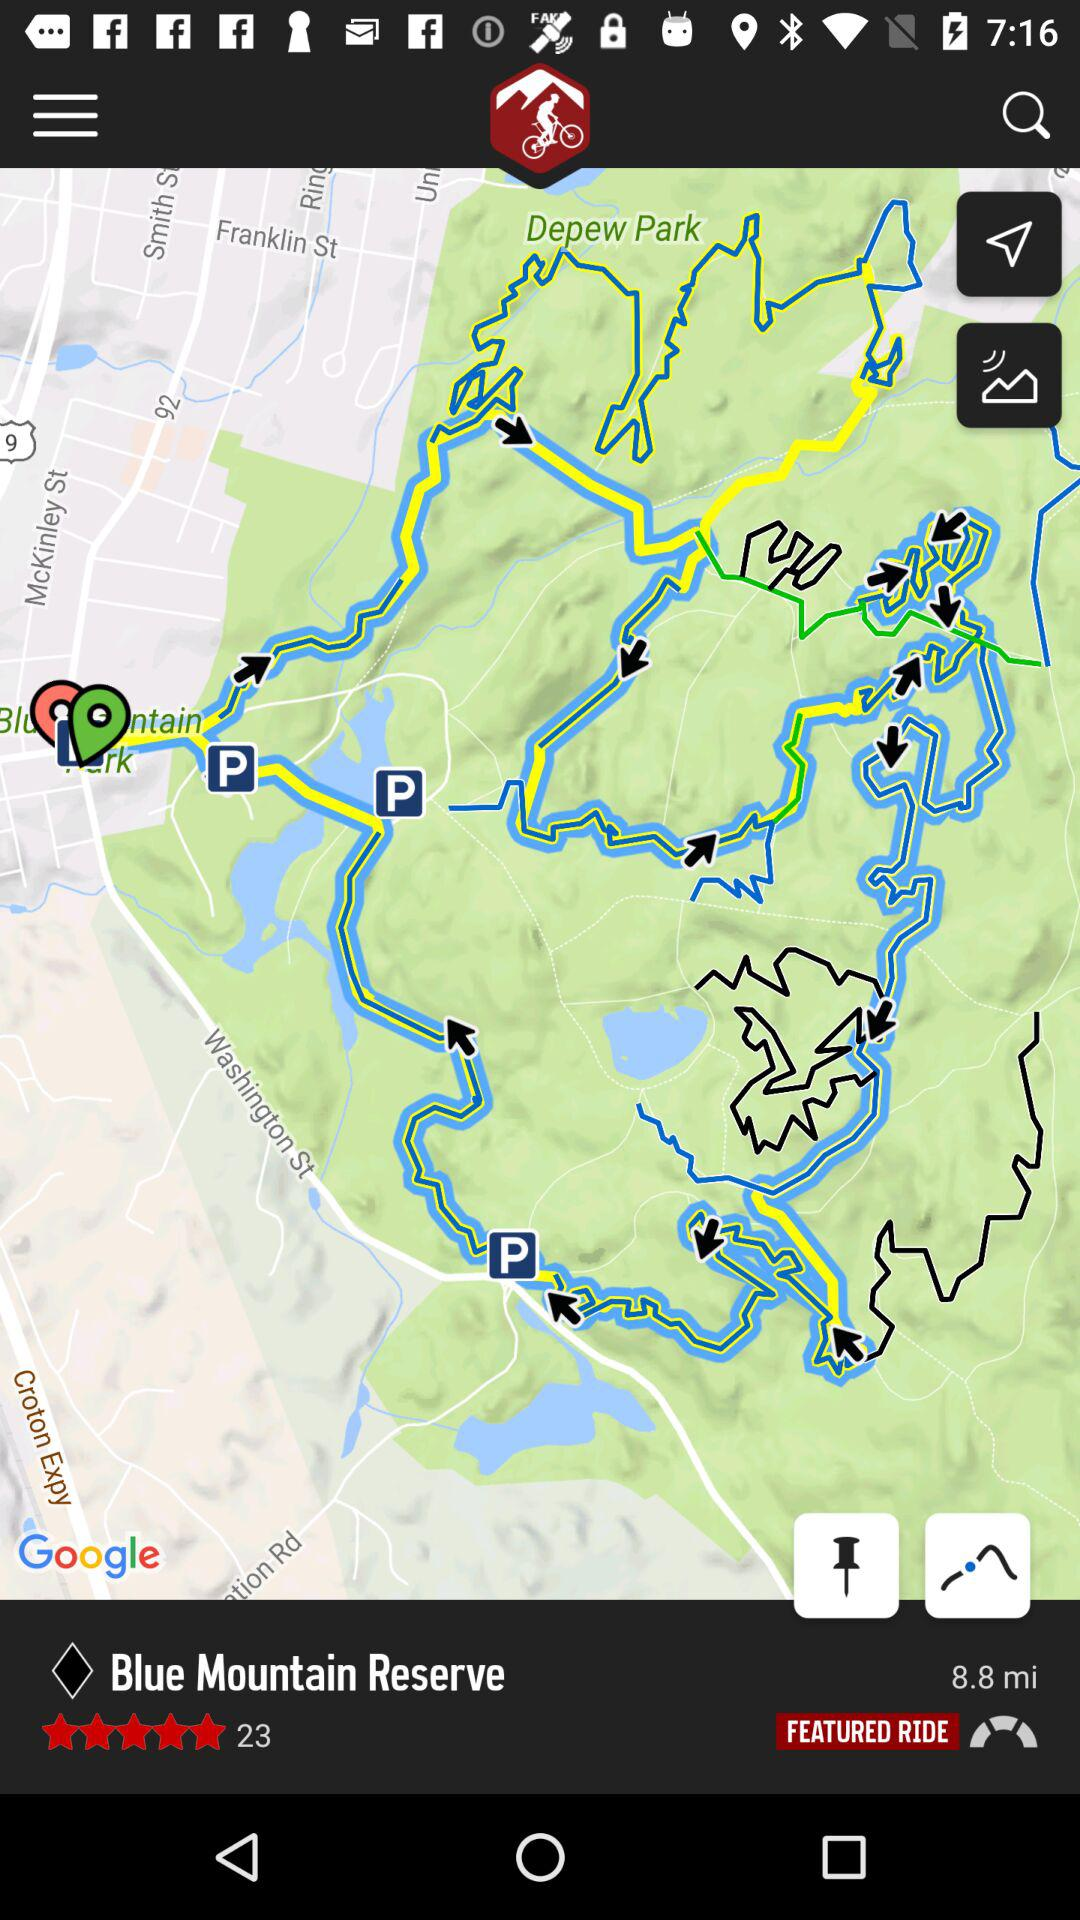In which city is "Blue Mountain Reserve" located?
When the provided information is insufficient, respond with <no answer>. <no answer> 